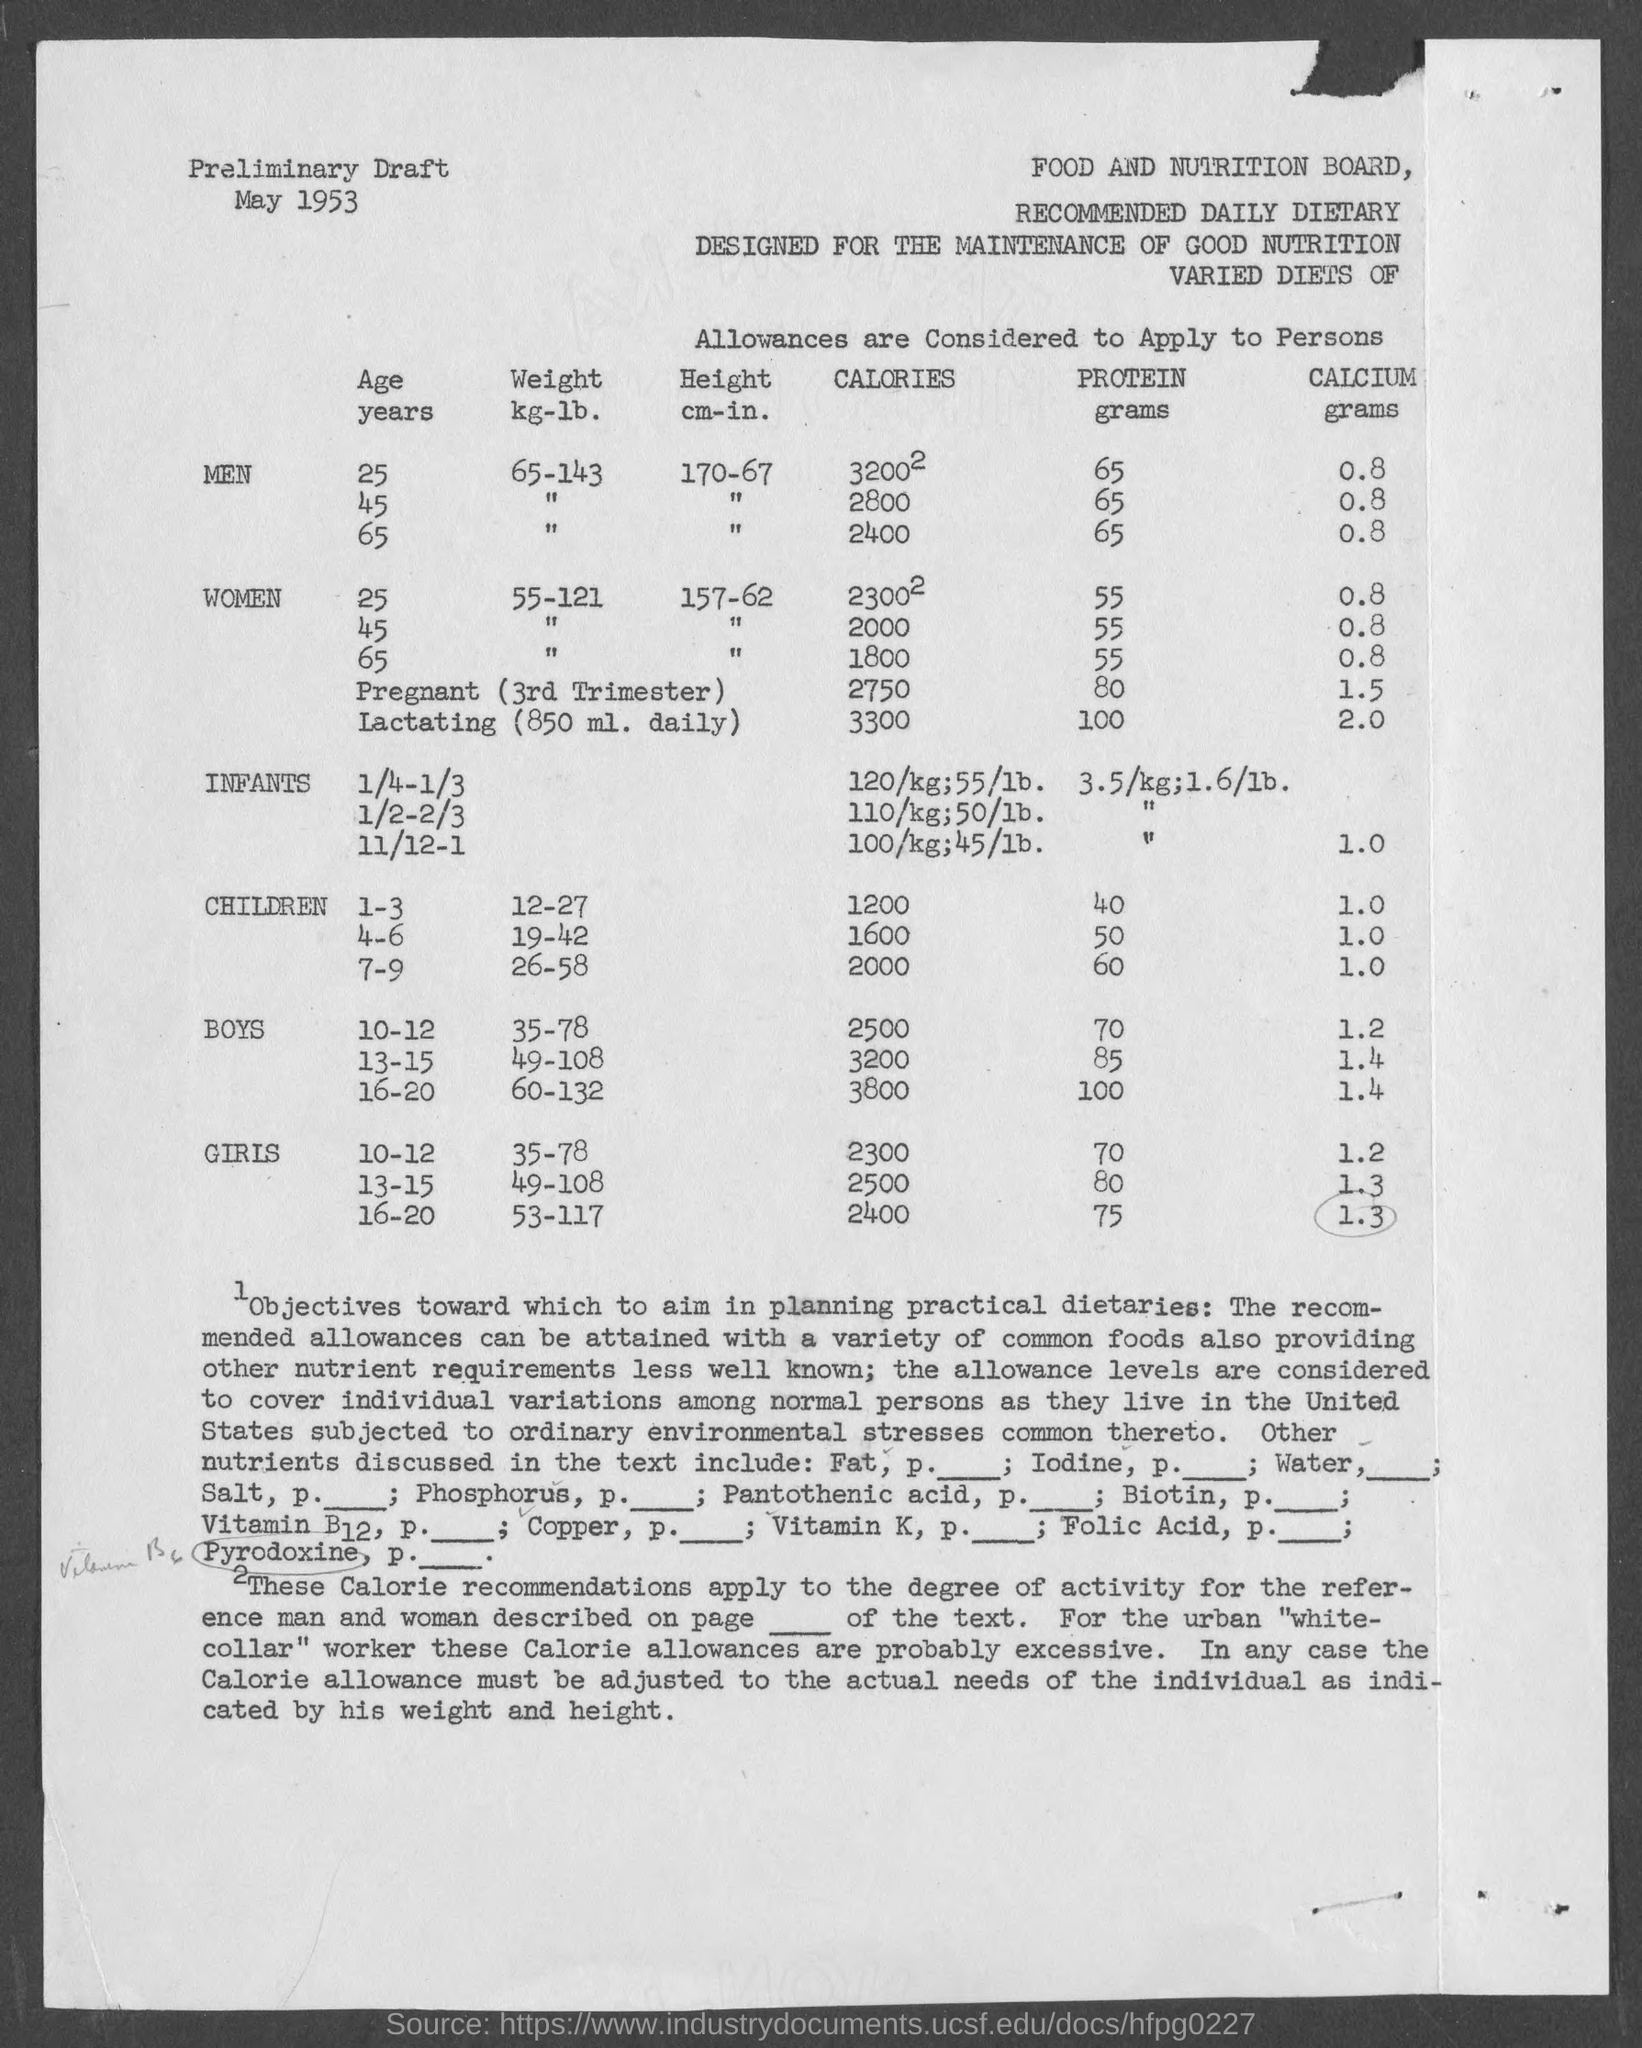Identify some key points in this picture. The weight, in both kilograms and pounds, for men aged 25 years is 65-143. The Food and Nutrition Board is the name of the board mentioned in the given page. The height in cm-in for a 25-year-old woman is 157-62. For men aged 25 years, the height in centimeters is 170 with a negative sign before the number, indicating that the measurement is in inches. For men aged 25 years, the recommended daily amount of protein is X grams. 